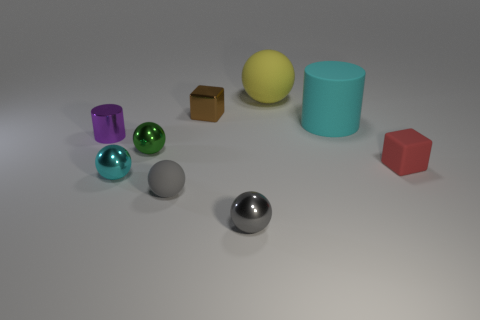Subtract all yellow balls. How many balls are left? 4 Subtract all yellow matte spheres. How many spheres are left? 4 Subtract 2 balls. How many balls are left? 3 Subtract all purple balls. Subtract all red cubes. How many balls are left? 5 Add 1 purple cylinders. How many objects exist? 10 Subtract all balls. How many objects are left? 4 Subtract 0 cyan cubes. How many objects are left? 9 Subtract all big yellow metallic things. Subtract all matte blocks. How many objects are left? 8 Add 7 yellow matte objects. How many yellow matte objects are left? 8 Add 4 brown metal things. How many brown metal things exist? 5 